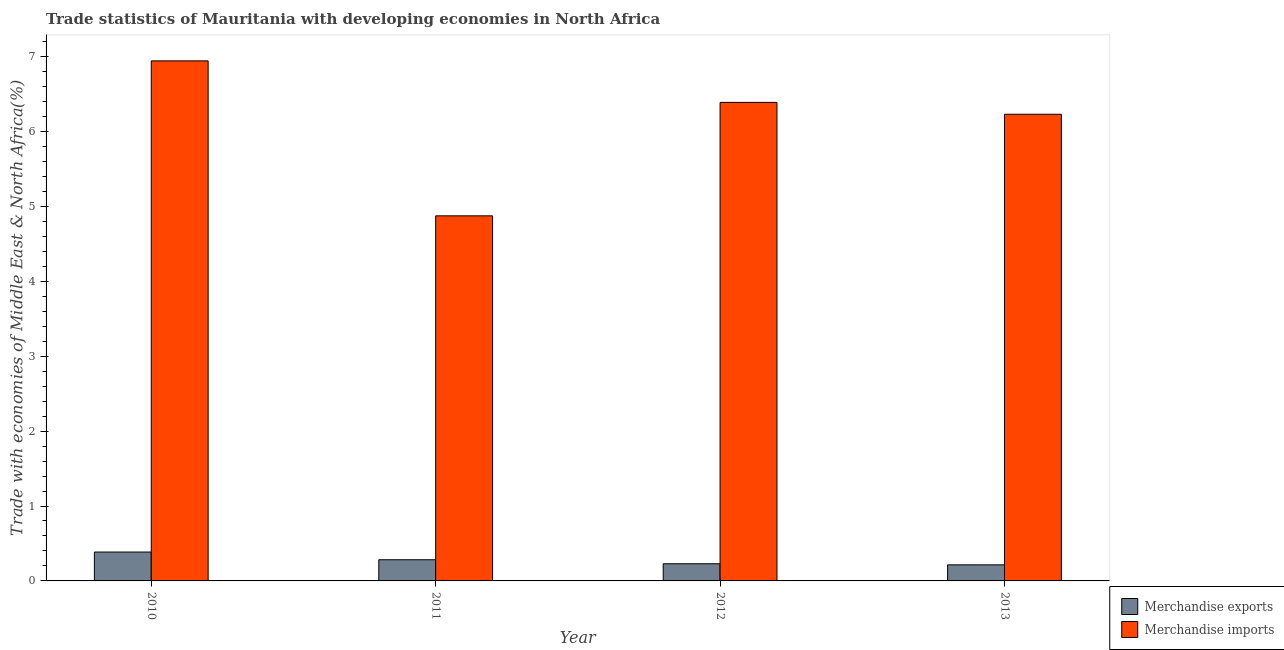How many different coloured bars are there?
Ensure brevity in your answer.  2. How many groups of bars are there?
Provide a succinct answer. 4. Are the number of bars per tick equal to the number of legend labels?
Provide a succinct answer. Yes. What is the label of the 2nd group of bars from the left?
Provide a short and direct response. 2011. In how many cases, is the number of bars for a given year not equal to the number of legend labels?
Make the answer very short. 0. What is the merchandise imports in 2011?
Your response must be concise. 4.87. Across all years, what is the maximum merchandise exports?
Your answer should be compact. 0.39. Across all years, what is the minimum merchandise imports?
Your response must be concise. 4.87. What is the total merchandise imports in the graph?
Your answer should be very brief. 24.43. What is the difference between the merchandise imports in 2010 and that in 2011?
Offer a very short reply. 2.07. What is the difference between the merchandise exports in 2013 and the merchandise imports in 2011?
Give a very brief answer. -0.07. What is the average merchandise imports per year?
Keep it short and to the point. 6.11. In how many years, is the merchandise exports greater than 2 %?
Make the answer very short. 0. What is the ratio of the merchandise imports in 2010 to that in 2013?
Provide a short and direct response. 1.11. Is the difference between the merchandise exports in 2011 and 2013 greater than the difference between the merchandise imports in 2011 and 2013?
Provide a short and direct response. No. What is the difference between the highest and the second highest merchandise imports?
Make the answer very short. 0.55. What is the difference between the highest and the lowest merchandise exports?
Your answer should be compact. 0.17. How many bars are there?
Offer a terse response. 8. Are all the bars in the graph horizontal?
Provide a short and direct response. No. How many years are there in the graph?
Give a very brief answer. 4. Are the values on the major ticks of Y-axis written in scientific E-notation?
Ensure brevity in your answer.  No. Does the graph contain grids?
Provide a short and direct response. No. How are the legend labels stacked?
Keep it short and to the point. Vertical. What is the title of the graph?
Ensure brevity in your answer.  Trade statistics of Mauritania with developing economies in North Africa. Does "International Visitors" appear as one of the legend labels in the graph?
Ensure brevity in your answer.  No. What is the label or title of the Y-axis?
Give a very brief answer. Trade with economies of Middle East & North Africa(%). What is the Trade with economies of Middle East & North Africa(%) in Merchandise exports in 2010?
Your answer should be very brief. 0.39. What is the Trade with economies of Middle East & North Africa(%) of Merchandise imports in 2010?
Keep it short and to the point. 6.94. What is the Trade with economies of Middle East & North Africa(%) of Merchandise exports in 2011?
Keep it short and to the point. 0.28. What is the Trade with economies of Middle East & North Africa(%) in Merchandise imports in 2011?
Provide a succinct answer. 4.87. What is the Trade with economies of Middle East & North Africa(%) in Merchandise exports in 2012?
Your answer should be compact. 0.23. What is the Trade with economies of Middle East & North Africa(%) of Merchandise imports in 2012?
Offer a very short reply. 6.39. What is the Trade with economies of Middle East & North Africa(%) in Merchandise exports in 2013?
Give a very brief answer. 0.21. What is the Trade with economies of Middle East & North Africa(%) in Merchandise imports in 2013?
Make the answer very short. 6.23. Across all years, what is the maximum Trade with economies of Middle East & North Africa(%) of Merchandise exports?
Make the answer very short. 0.39. Across all years, what is the maximum Trade with economies of Middle East & North Africa(%) in Merchandise imports?
Your answer should be compact. 6.94. Across all years, what is the minimum Trade with economies of Middle East & North Africa(%) of Merchandise exports?
Your answer should be very brief. 0.21. Across all years, what is the minimum Trade with economies of Middle East & North Africa(%) of Merchandise imports?
Offer a very short reply. 4.87. What is the total Trade with economies of Middle East & North Africa(%) in Merchandise exports in the graph?
Make the answer very short. 1.11. What is the total Trade with economies of Middle East & North Africa(%) in Merchandise imports in the graph?
Make the answer very short. 24.43. What is the difference between the Trade with economies of Middle East & North Africa(%) of Merchandise exports in 2010 and that in 2011?
Provide a short and direct response. 0.1. What is the difference between the Trade with economies of Middle East & North Africa(%) of Merchandise imports in 2010 and that in 2011?
Offer a very short reply. 2.07. What is the difference between the Trade with economies of Middle East & North Africa(%) in Merchandise exports in 2010 and that in 2012?
Offer a very short reply. 0.16. What is the difference between the Trade with economies of Middle East & North Africa(%) of Merchandise imports in 2010 and that in 2012?
Make the answer very short. 0.55. What is the difference between the Trade with economies of Middle East & North Africa(%) in Merchandise exports in 2010 and that in 2013?
Your response must be concise. 0.17. What is the difference between the Trade with economies of Middle East & North Africa(%) in Merchandise imports in 2010 and that in 2013?
Your answer should be compact. 0.71. What is the difference between the Trade with economies of Middle East & North Africa(%) of Merchandise exports in 2011 and that in 2012?
Provide a succinct answer. 0.05. What is the difference between the Trade with economies of Middle East & North Africa(%) in Merchandise imports in 2011 and that in 2012?
Offer a very short reply. -1.51. What is the difference between the Trade with economies of Middle East & North Africa(%) in Merchandise exports in 2011 and that in 2013?
Offer a terse response. 0.07. What is the difference between the Trade with economies of Middle East & North Africa(%) of Merchandise imports in 2011 and that in 2013?
Your response must be concise. -1.36. What is the difference between the Trade with economies of Middle East & North Africa(%) of Merchandise exports in 2012 and that in 2013?
Keep it short and to the point. 0.01. What is the difference between the Trade with economies of Middle East & North Africa(%) in Merchandise imports in 2012 and that in 2013?
Offer a terse response. 0.16. What is the difference between the Trade with economies of Middle East & North Africa(%) of Merchandise exports in 2010 and the Trade with economies of Middle East & North Africa(%) of Merchandise imports in 2011?
Give a very brief answer. -4.49. What is the difference between the Trade with economies of Middle East & North Africa(%) in Merchandise exports in 2010 and the Trade with economies of Middle East & North Africa(%) in Merchandise imports in 2012?
Provide a succinct answer. -6. What is the difference between the Trade with economies of Middle East & North Africa(%) in Merchandise exports in 2010 and the Trade with economies of Middle East & North Africa(%) in Merchandise imports in 2013?
Keep it short and to the point. -5.84. What is the difference between the Trade with economies of Middle East & North Africa(%) of Merchandise exports in 2011 and the Trade with economies of Middle East & North Africa(%) of Merchandise imports in 2012?
Ensure brevity in your answer.  -6.1. What is the difference between the Trade with economies of Middle East & North Africa(%) in Merchandise exports in 2011 and the Trade with economies of Middle East & North Africa(%) in Merchandise imports in 2013?
Offer a terse response. -5.95. What is the difference between the Trade with economies of Middle East & North Africa(%) in Merchandise exports in 2012 and the Trade with economies of Middle East & North Africa(%) in Merchandise imports in 2013?
Give a very brief answer. -6. What is the average Trade with economies of Middle East & North Africa(%) of Merchandise exports per year?
Offer a terse response. 0.28. What is the average Trade with economies of Middle East & North Africa(%) in Merchandise imports per year?
Offer a very short reply. 6.11. In the year 2010, what is the difference between the Trade with economies of Middle East & North Africa(%) of Merchandise exports and Trade with economies of Middle East & North Africa(%) of Merchandise imports?
Give a very brief answer. -6.56. In the year 2011, what is the difference between the Trade with economies of Middle East & North Africa(%) of Merchandise exports and Trade with economies of Middle East & North Africa(%) of Merchandise imports?
Give a very brief answer. -4.59. In the year 2012, what is the difference between the Trade with economies of Middle East & North Africa(%) of Merchandise exports and Trade with economies of Middle East & North Africa(%) of Merchandise imports?
Ensure brevity in your answer.  -6.16. In the year 2013, what is the difference between the Trade with economies of Middle East & North Africa(%) in Merchandise exports and Trade with economies of Middle East & North Africa(%) in Merchandise imports?
Make the answer very short. -6.01. What is the ratio of the Trade with economies of Middle East & North Africa(%) in Merchandise exports in 2010 to that in 2011?
Offer a very short reply. 1.36. What is the ratio of the Trade with economies of Middle East & North Africa(%) in Merchandise imports in 2010 to that in 2011?
Offer a very short reply. 1.42. What is the ratio of the Trade with economies of Middle East & North Africa(%) in Merchandise exports in 2010 to that in 2012?
Offer a terse response. 1.68. What is the ratio of the Trade with economies of Middle East & North Africa(%) of Merchandise imports in 2010 to that in 2012?
Give a very brief answer. 1.09. What is the ratio of the Trade with economies of Middle East & North Africa(%) in Merchandise exports in 2010 to that in 2013?
Offer a very short reply. 1.8. What is the ratio of the Trade with economies of Middle East & North Africa(%) in Merchandise imports in 2010 to that in 2013?
Provide a succinct answer. 1.11. What is the ratio of the Trade with economies of Middle East & North Africa(%) of Merchandise exports in 2011 to that in 2012?
Offer a terse response. 1.23. What is the ratio of the Trade with economies of Middle East & North Africa(%) in Merchandise imports in 2011 to that in 2012?
Provide a short and direct response. 0.76. What is the ratio of the Trade with economies of Middle East & North Africa(%) of Merchandise exports in 2011 to that in 2013?
Provide a succinct answer. 1.32. What is the ratio of the Trade with economies of Middle East & North Africa(%) in Merchandise imports in 2011 to that in 2013?
Offer a terse response. 0.78. What is the ratio of the Trade with economies of Middle East & North Africa(%) of Merchandise exports in 2012 to that in 2013?
Provide a short and direct response. 1.07. What is the ratio of the Trade with economies of Middle East & North Africa(%) of Merchandise imports in 2012 to that in 2013?
Provide a succinct answer. 1.03. What is the difference between the highest and the second highest Trade with economies of Middle East & North Africa(%) in Merchandise exports?
Your answer should be very brief. 0.1. What is the difference between the highest and the second highest Trade with economies of Middle East & North Africa(%) of Merchandise imports?
Keep it short and to the point. 0.55. What is the difference between the highest and the lowest Trade with economies of Middle East & North Africa(%) in Merchandise exports?
Provide a short and direct response. 0.17. What is the difference between the highest and the lowest Trade with economies of Middle East & North Africa(%) in Merchandise imports?
Provide a short and direct response. 2.07. 